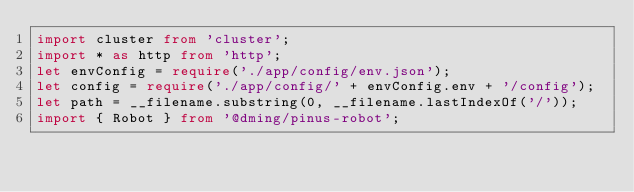Convert code to text. <code><loc_0><loc_0><loc_500><loc_500><_TypeScript_>import cluster from 'cluster';
import * as http from 'http';
let envConfig = require('./app/config/env.json');
let config = require('./app/config/' + envConfig.env + '/config');
let path = __filename.substring(0, __filename.lastIndexOf('/'));
import { Robot } from '@dming/pinus-robot';
</code> 